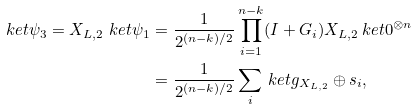<formula> <loc_0><loc_0><loc_500><loc_500>\ k e t { \psi _ { 3 } } = X _ { L , 2 } \ k e t { \psi _ { 1 } } & = \frac { 1 } { 2 ^ { ( n - k ) / 2 } } \prod _ { i = 1 } ^ { n - k } ( I + G _ { i } ) X _ { L , 2 } \ k e t { 0 } ^ { \otimes n } \\ & = \frac { 1 } { 2 ^ { ( n - k ) / 2 } } \sum _ { i } \ k e t { g _ { X _ { L , 2 } } \oplus s _ { i } } ,</formula> 